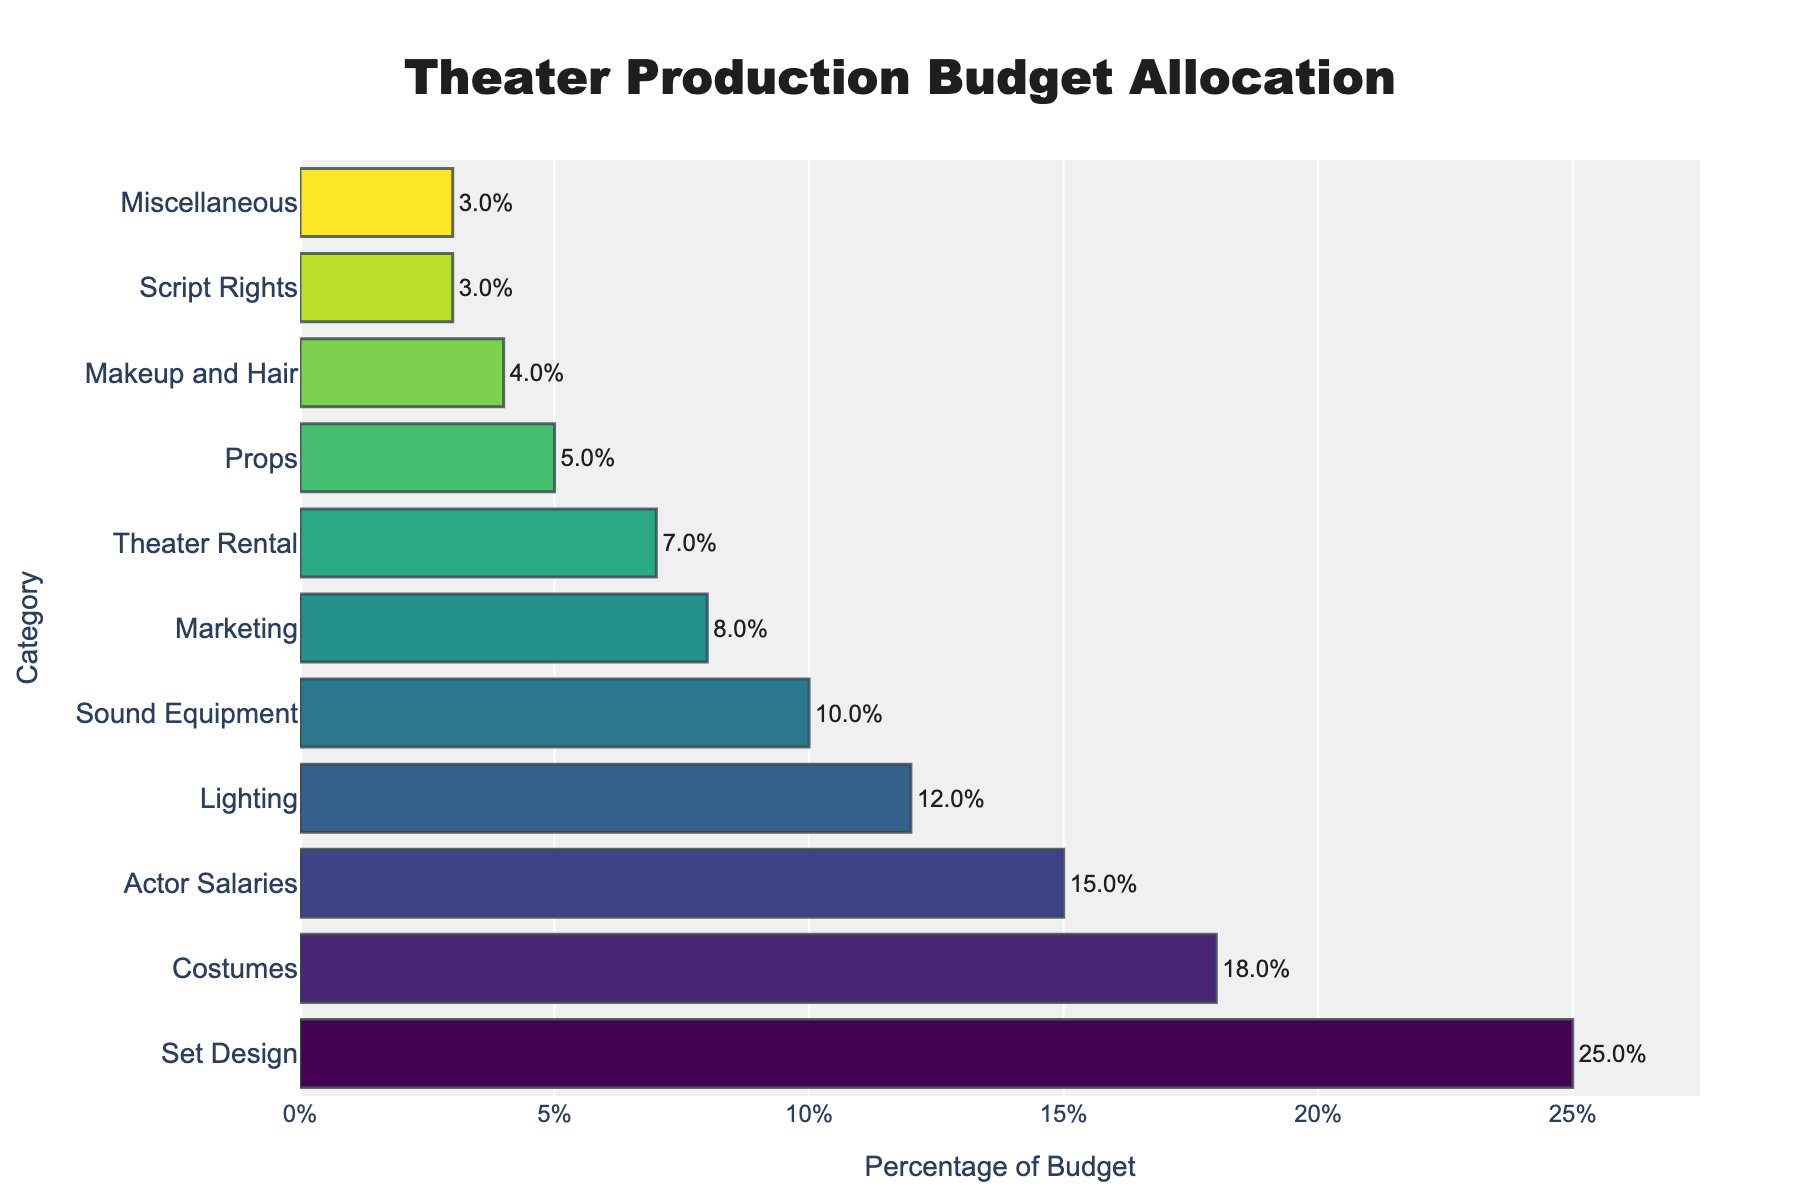what category receives the highest percentage of the budget? The bar chart shows that "Set Design" has the longest bar, indicating it receives the largest percentage of the budget.
Answer: Set Design Which category has a higher budget allocation: Actor Salaries or Costumes? By comparing the bar lengths, "Costumes" has a longer bar than "Actor Salaries," indicating a higher budget allocation.
Answer: Costumes How much more percentage is allocated to Sound Equipment compared to Miscellaneous? The bar for Sound Equipment indicates 10%, and the bar for Miscellaneous indicates 3%. The difference is 10% - 3% = 7%.
Answer: 7% Which categories receive less than 10% of the budget? The bars for "Makeup and Hair," "Script Rights," "Miscellaneous," "Props," "Theater Rental," and "Marketing" are shorter than the 10% mark.
Answer: Makeup and Hair, Script Rights, Miscellaneous, Props, Theater Rental, Marketing What's the total percentage allocated to Set Design, Costumes, and Actor Salaries? The percentages are 25% for Set Design, 18% for Costumes, and 15% for Actor Salaries. The total is 25% + 18% + 15% = 58%.
Answer: 58% Compare the combined percentage of Lighting and Sound Equipment to that of Marketing and Theater Rental. Which pair has a higher budget allocation? Lighting is 12% and Sound Equipment is 10%, totaling 22%. Marketing is 8% and Theater Rental is 7%, totaling 15%. The Lighting and Sound Equipment pair has a higher budget allocation.
Answer: Lighting and Sound Equipment What is the average percentage allocation for the categories with less than 5%? The categories under 5% are Makeup and Hair (4%), Script Rights (3%), and Miscellaneous (3%). The average is (4% + 3% + 3%) / 3 = 10% / 3 ≈ 3.33%.
Answer: 3.33% If the Props budget is increased by 2%, what will be the new percentage? The current Props budget is 5%. Adding 2% makes it 5% + 2% = 7%.
Answer: 7% Which category has a closer percentage to Lighting, and by how much? Lighting is at 12%. Actor Salaries is at 15%, and Sound Equipment is at 10%. The difference between Lighting and Sound Equipment is 2%, which is less than the difference with Actor Salaries (3%).
Answer: Sound Equipment, 2% 